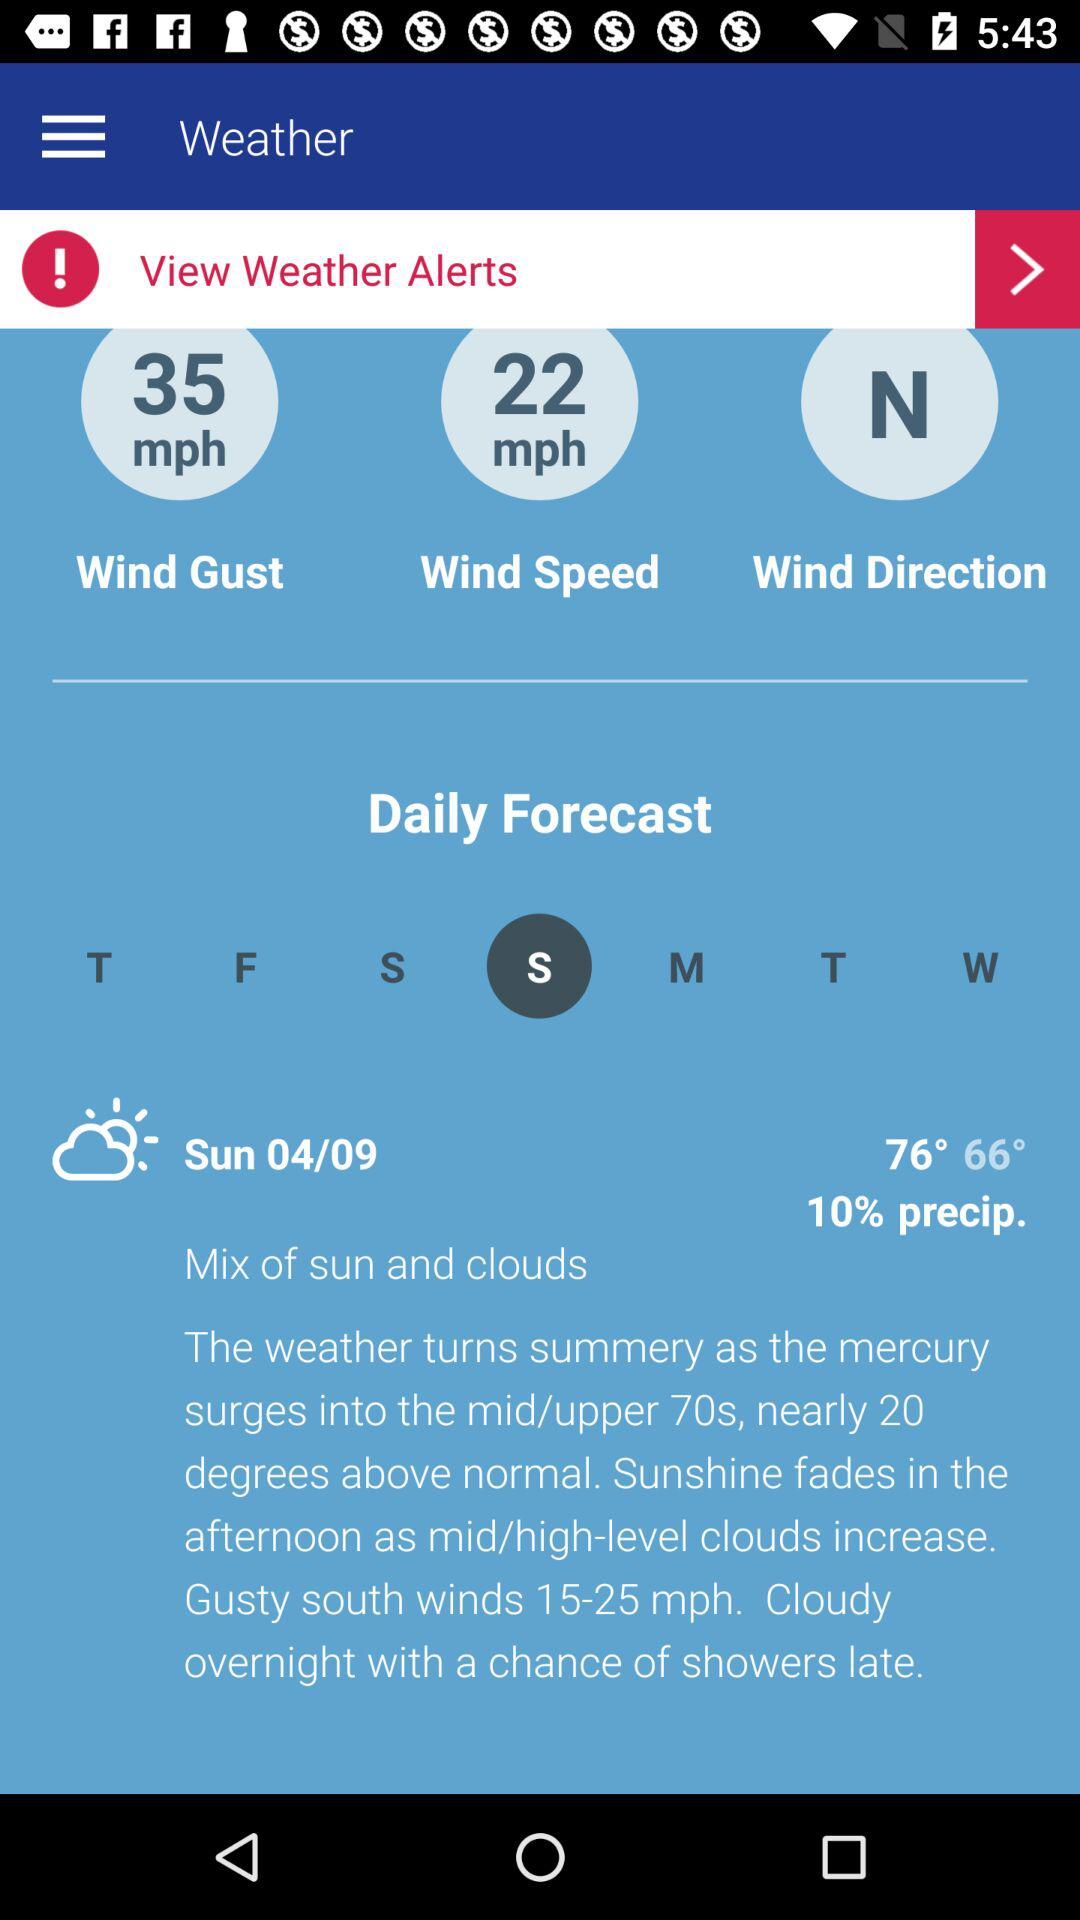What is the wind speed? The wind speed is 22 mph. 